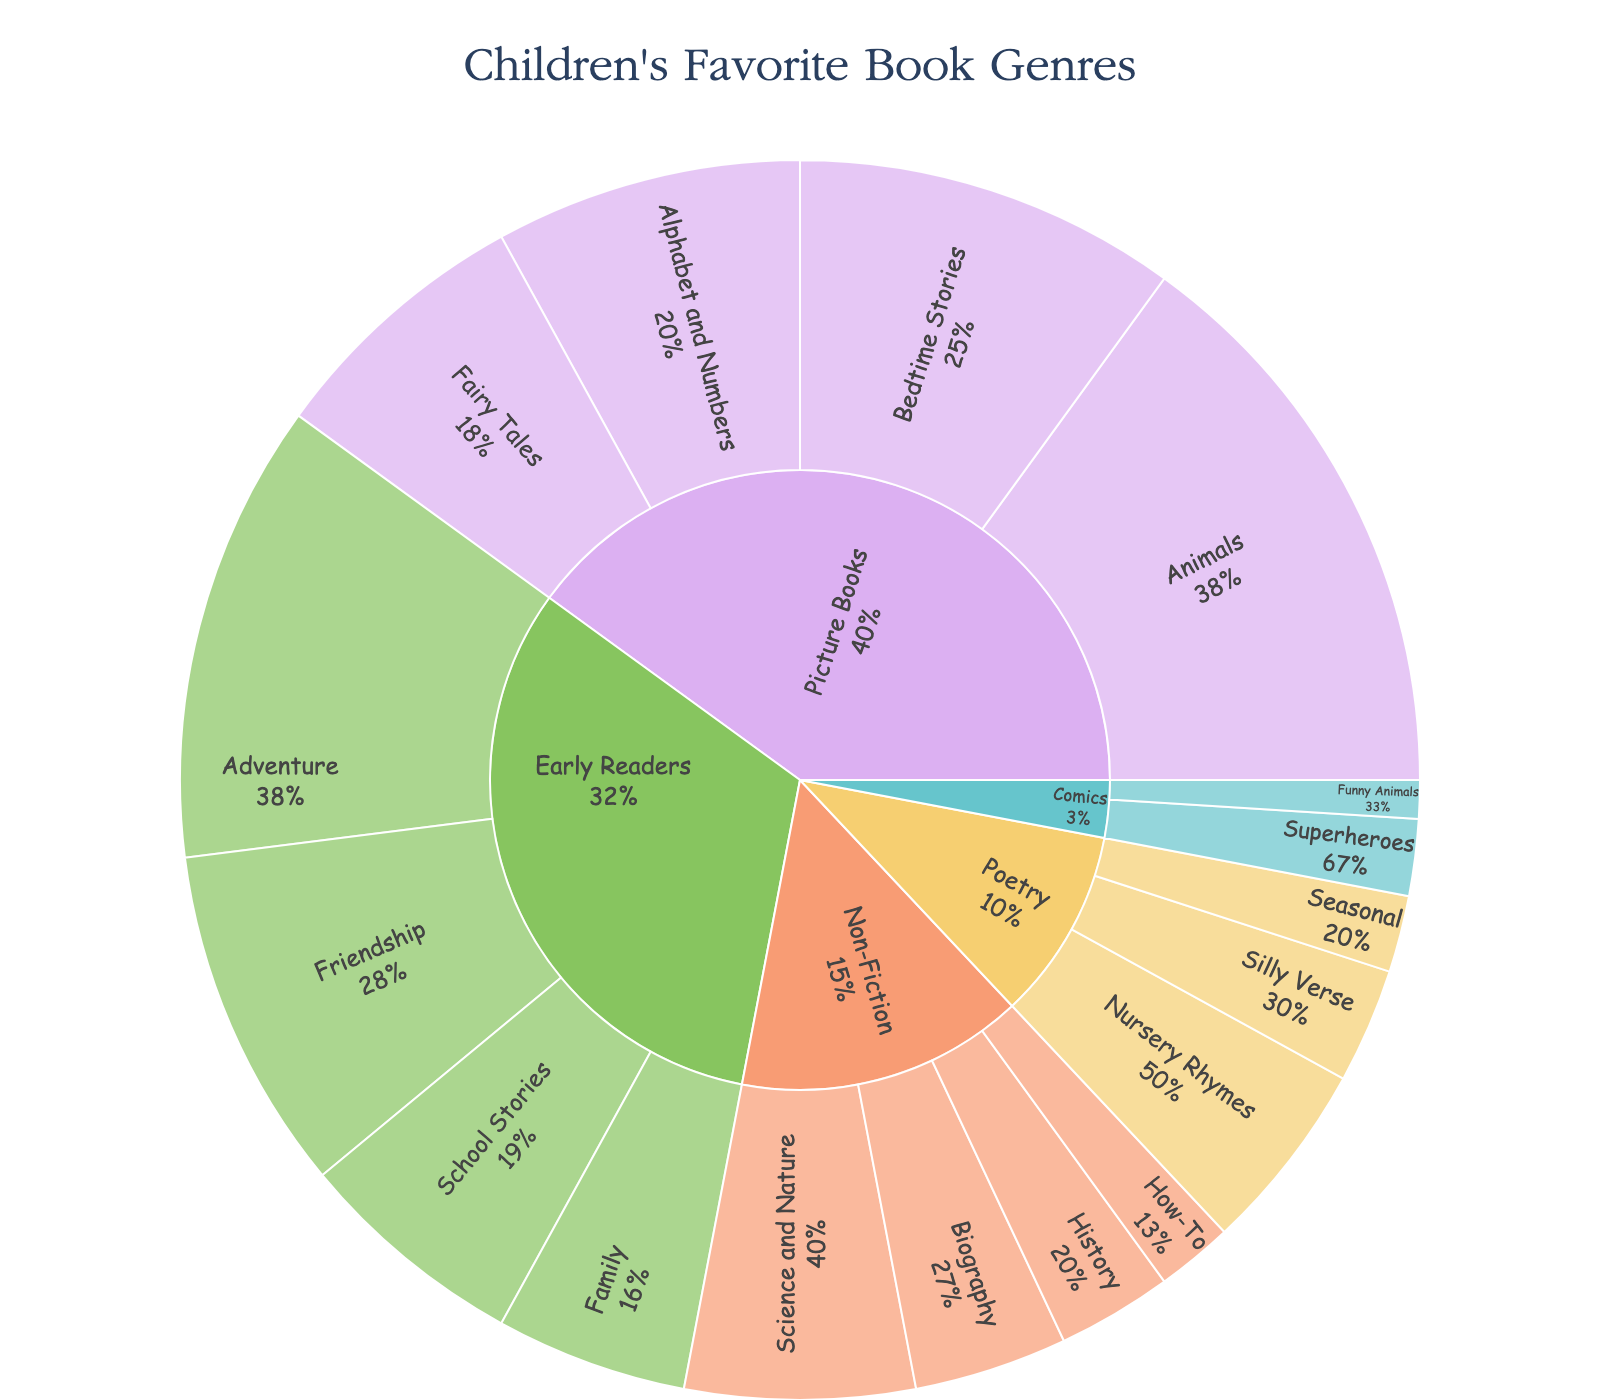what is the title of the plot? The title is prominently displayed at the top of the plot. By reading the textual information there, we find the title.
Answer: Children's Favorite Book Genres Which genre has the highest percentage of children's favorite books? To find out which genre has the highest percentage, look at the largest section of the outermost ring.
Answer: Picture Books Which subgenre under Picture Books has the smallest percentage? To identify this, look at the segments within the Picture Books section and compare their sizes.
Answer: Fairy Tales How many subgenres are there in the Non-Fiction genre? To determine the number of subgenres, count the different sections within the Non-Fiction part of the plot.
Answer: 4 What is the combined percentage of subgenre percentages for Early Readers? To get this, add the percentages of all subgenres within the Early Readers section: Adventure (12), Friendship (9), School Stories (6), and Family (5).
Answer: 32% Is there a genre with an overall percentage less than the total for the Poetry genre? First, sum the subgenre percentages under Poetry: Nursery Rhymes (5), Silly Verse (3), and Seasonal (2), total: 10%. Compare this sum with the percentages of other genres.
Answer: Yes, Comics (3%) Which subgenre under Early Readers has the same percentage as the Nursery Rhymes subgenre of Poetry? Compare the percentage figures provided within Early Readers subgenres with the 5% for Nursery Rhymes under Poetry.
Answer: Family What is the percentage difference between the Animals subgenre in Picture Books and the Science and Nature subgenre in Non-Fiction? Subtract the percentage of Science and Nature (6%) from Animals (15%).
Answer: 9% Which two genres combined have the closest total percentage to Picture Books? Calculate the total for each genre and find two genres whose combined percentage (Early Readers 32%, Non-Fiction 15%, Poetry 10%, Comics 3%) is closest to 40%.
Answer: Early Readers and Non-Fiction Which subgenre within Non-Fiction has the smallest percentage? Look at the sections within Non-Fiction and identify the smallest one.
Answer: How-To 